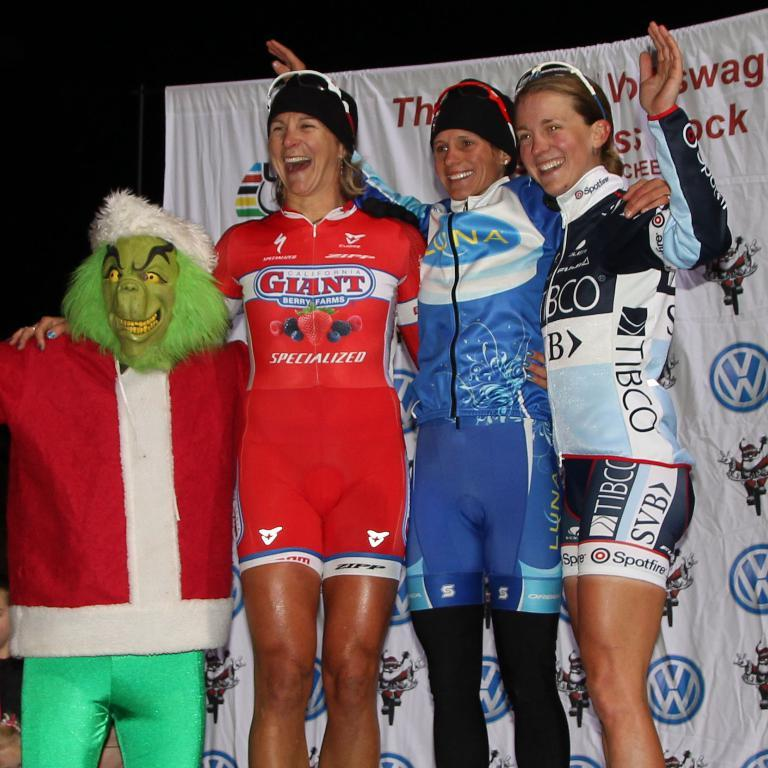Provide a one-sentence caption for the provided image. Sponsor Giant Berry Farms have various berries on the red uniform. 